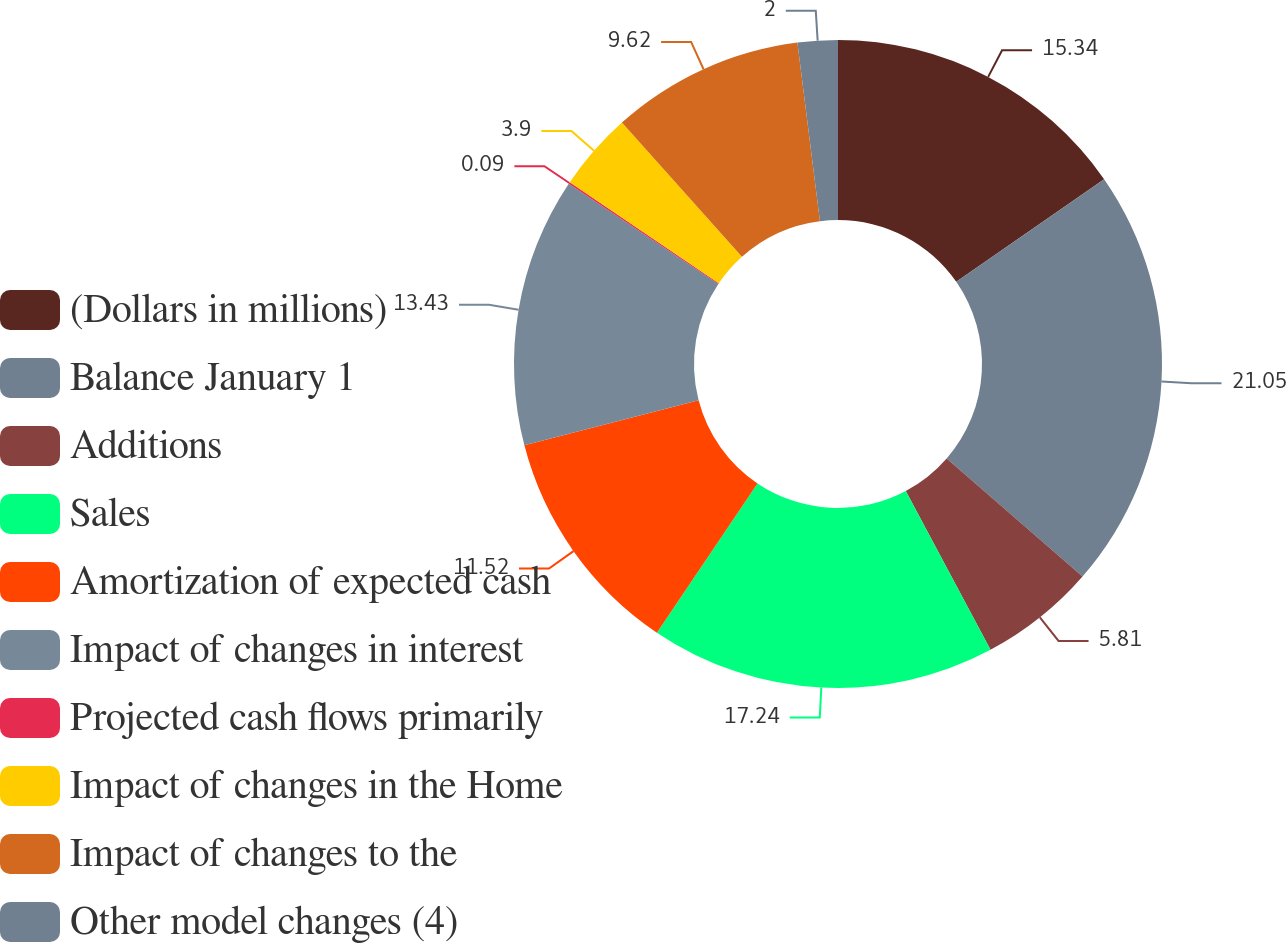Convert chart. <chart><loc_0><loc_0><loc_500><loc_500><pie_chart><fcel>(Dollars in millions)<fcel>Balance January 1<fcel>Additions<fcel>Sales<fcel>Amortization of expected cash<fcel>Impact of changes in interest<fcel>Projected cash flows primarily<fcel>Impact of changes in the Home<fcel>Impact of changes to the<fcel>Other model changes (4)<nl><fcel>15.34%<fcel>21.05%<fcel>5.81%<fcel>17.24%<fcel>11.52%<fcel>13.43%<fcel>0.09%<fcel>3.9%<fcel>9.62%<fcel>2.0%<nl></chart> 